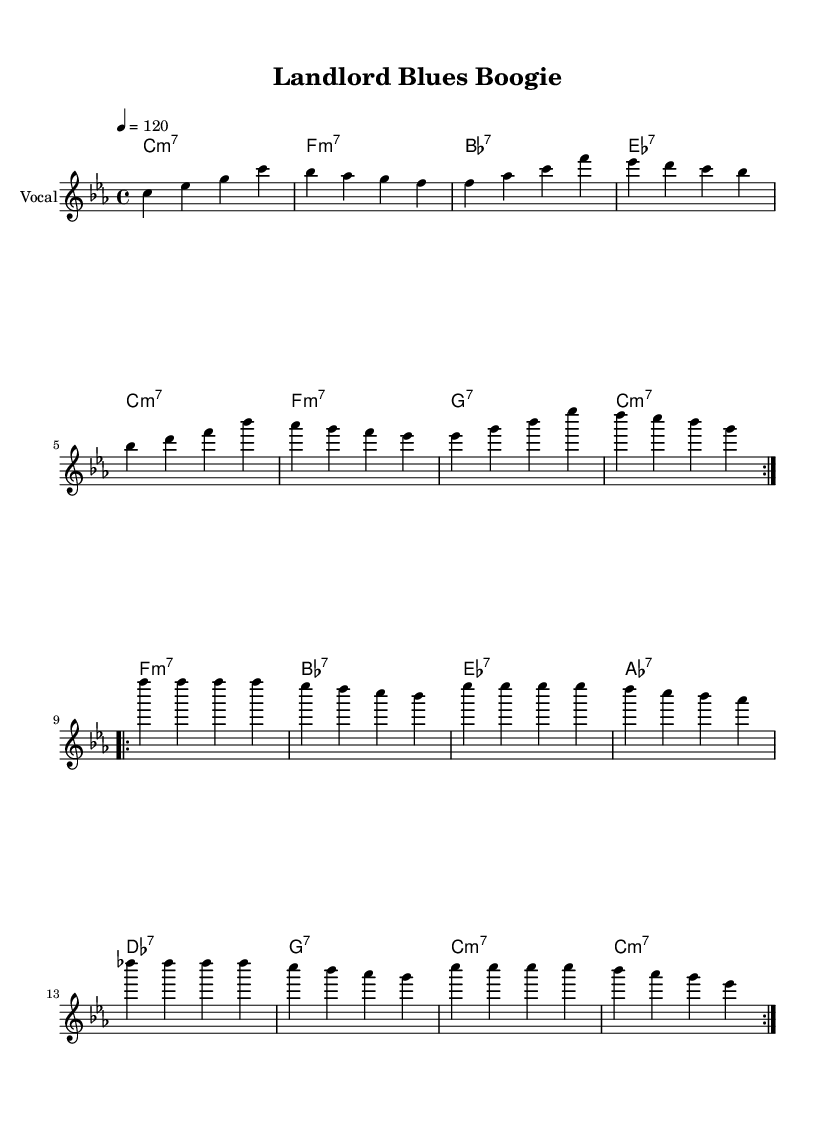What is the key signature of this music? The key signature indicated in the global settings is C minor, which has three flats (B-flat, E-flat, and A-flat).
Answer: C minor What is the time signature of this music? The time signature shown in the global settings is 4/4, meaning there are four beats in each measure, and the quarter note gets one beat.
Answer: 4/4 What is the tempo of this piece? The tempo is marked as “4 = 120”, which means the quarter note should be played at a tempo of 120 beats per minute.
Answer: 120 How many measures are repeated in the first section? The first section, marked with “\repeat volta 2,” indicates that this section is repeated twice, meaning there are two repetitions for the measures in that section.
Answer: 2 What is the primary theme expressed in the lyrics? The lyrics express frustration and dissatisfaction with a landlord who is unresponsive to maintenance issues in the apartment, reflecting a struggle with authority.
Answer: Frustration with landlord Which musical element is primarily used to express the disco style in this piece? The use of syncopated rhythms and the groove created by the bass lines and harmonies is a characteristic element of disco music, fostering a danceable feel.
Answer: Groove What type of chords are predominantly used in the harmonies? The chords are primarily seventh chords, which are common in jazz and funk genres and are used here to add richness to the disco sound.
Answer: Seventh chords 